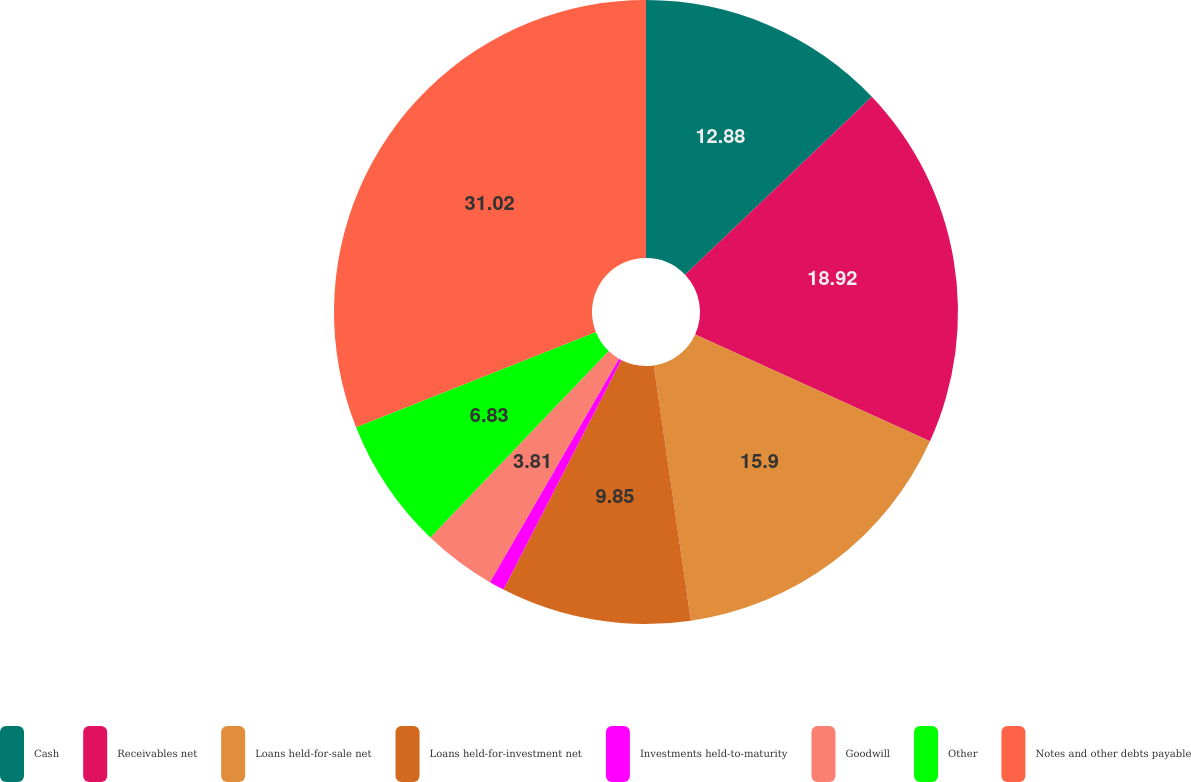<chart> <loc_0><loc_0><loc_500><loc_500><pie_chart><fcel>Cash<fcel>Receivables net<fcel>Loans held-for-sale net<fcel>Loans held-for-investment net<fcel>Investments held-to-maturity<fcel>Goodwill<fcel>Other<fcel>Notes and other debts payable<nl><fcel>12.88%<fcel>18.92%<fcel>15.9%<fcel>9.85%<fcel>0.79%<fcel>3.81%<fcel>6.83%<fcel>31.02%<nl></chart> 